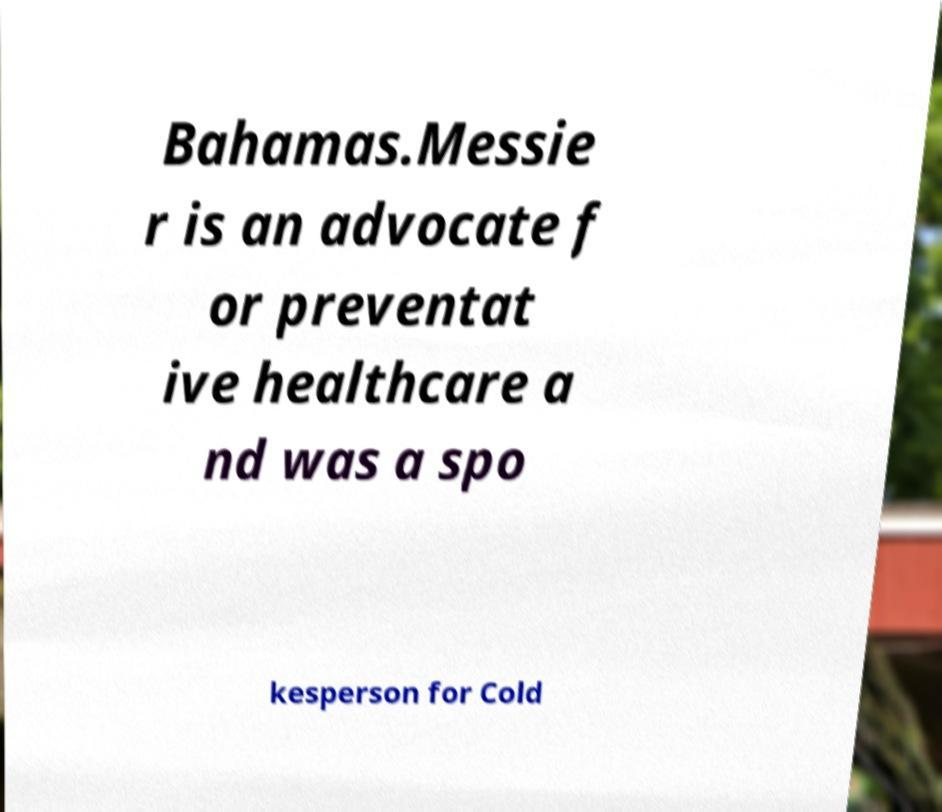Please read and relay the text visible in this image. What does it say? Bahamas.Messie r is an advocate f or preventat ive healthcare a nd was a spo kesperson for Cold 